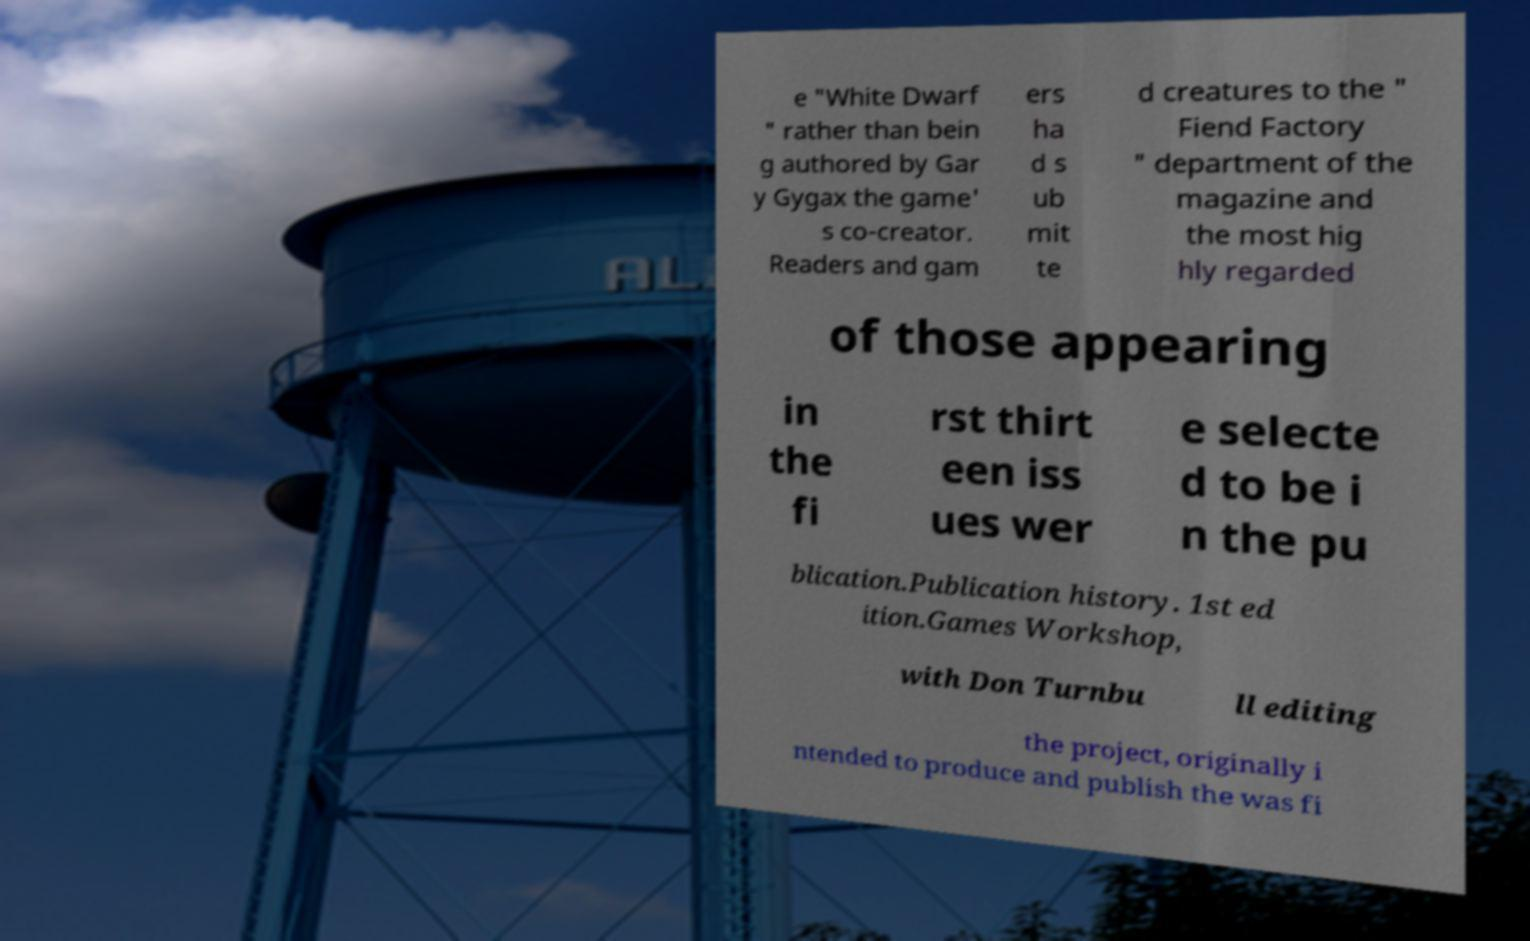Could you extract and type out the text from this image? e "White Dwarf " rather than bein g authored by Gar y Gygax the game' s co-creator. Readers and gam ers ha d s ub mit te d creatures to the " Fiend Factory " department of the magazine and the most hig hly regarded of those appearing in the fi rst thirt een iss ues wer e selecte d to be i n the pu blication.Publication history. 1st ed ition.Games Workshop, with Don Turnbu ll editing the project, originally i ntended to produce and publish the was fi 